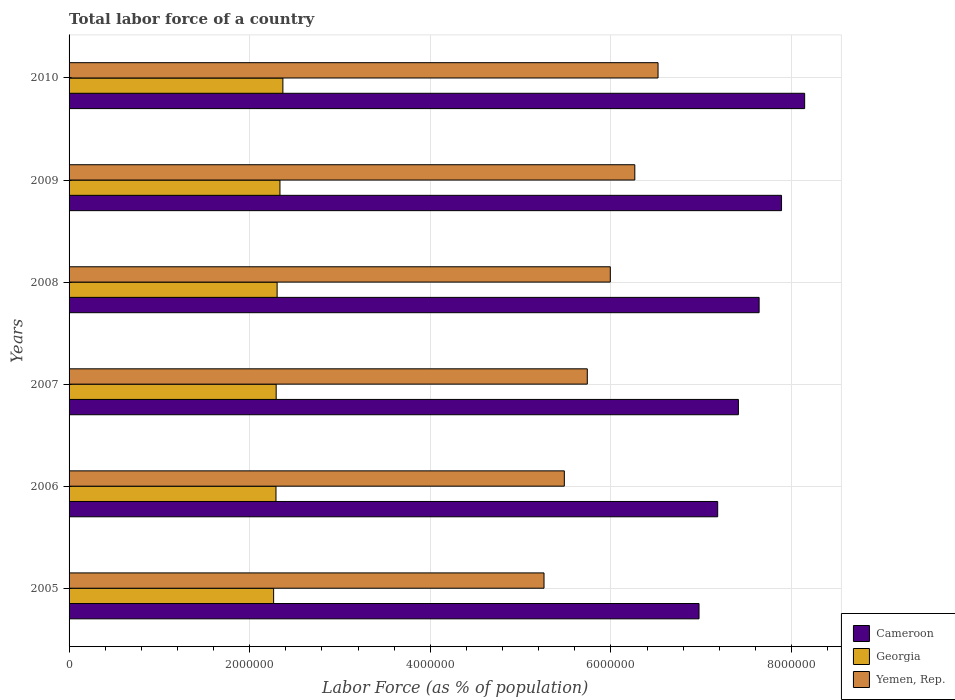Are the number of bars on each tick of the Y-axis equal?
Give a very brief answer. Yes. How many bars are there on the 3rd tick from the top?
Provide a succinct answer. 3. What is the label of the 1st group of bars from the top?
Provide a succinct answer. 2010. What is the percentage of labor force in Cameroon in 2010?
Provide a succinct answer. 8.14e+06. Across all years, what is the maximum percentage of labor force in Cameroon?
Offer a very short reply. 8.14e+06. Across all years, what is the minimum percentage of labor force in Yemen, Rep.?
Your response must be concise. 5.26e+06. In which year was the percentage of labor force in Yemen, Rep. maximum?
Offer a terse response. 2010. What is the total percentage of labor force in Cameroon in the graph?
Ensure brevity in your answer.  4.52e+07. What is the difference between the percentage of labor force in Georgia in 2006 and that in 2010?
Offer a terse response. -7.65e+04. What is the difference between the percentage of labor force in Georgia in 2010 and the percentage of labor force in Cameroon in 2008?
Provide a succinct answer. -5.27e+06. What is the average percentage of labor force in Cameroon per year?
Your answer should be very brief. 7.54e+06. In the year 2005, what is the difference between the percentage of labor force in Georgia and percentage of labor force in Cameroon?
Provide a succinct answer. -4.71e+06. In how many years, is the percentage of labor force in Georgia greater than 1600000 %?
Offer a very short reply. 6. What is the ratio of the percentage of labor force in Cameroon in 2006 to that in 2009?
Offer a terse response. 0.91. Is the percentage of labor force in Yemen, Rep. in 2008 less than that in 2010?
Provide a succinct answer. Yes. What is the difference between the highest and the second highest percentage of labor force in Cameroon?
Make the answer very short. 2.56e+05. What is the difference between the highest and the lowest percentage of labor force in Georgia?
Provide a short and direct response. 1.03e+05. In how many years, is the percentage of labor force in Yemen, Rep. greater than the average percentage of labor force in Yemen, Rep. taken over all years?
Your answer should be very brief. 3. What does the 3rd bar from the top in 2006 represents?
Make the answer very short. Cameroon. What does the 3rd bar from the bottom in 2008 represents?
Give a very brief answer. Yemen, Rep. How many bars are there?
Make the answer very short. 18. Are all the bars in the graph horizontal?
Offer a very short reply. Yes. What is the difference between two consecutive major ticks on the X-axis?
Offer a terse response. 2.00e+06. Does the graph contain any zero values?
Give a very brief answer. No. Does the graph contain grids?
Provide a short and direct response. Yes. Where does the legend appear in the graph?
Your answer should be very brief. Bottom right. What is the title of the graph?
Keep it short and to the point. Total labor force of a country. Does "Latvia" appear as one of the legend labels in the graph?
Provide a short and direct response. No. What is the label or title of the X-axis?
Keep it short and to the point. Labor Force (as % of population). What is the Labor Force (as % of population) of Cameroon in 2005?
Provide a short and direct response. 6.98e+06. What is the Labor Force (as % of population) of Georgia in 2005?
Ensure brevity in your answer.  2.26e+06. What is the Labor Force (as % of population) in Yemen, Rep. in 2005?
Your answer should be very brief. 5.26e+06. What is the Labor Force (as % of population) of Cameroon in 2006?
Keep it short and to the point. 7.18e+06. What is the Labor Force (as % of population) of Georgia in 2006?
Give a very brief answer. 2.29e+06. What is the Labor Force (as % of population) in Yemen, Rep. in 2006?
Give a very brief answer. 5.48e+06. What is the Labor Force (as % of population) in Cameroon in 2007?
Ensure brevity in your answer.  7.41e+06. What is the Labor Force (as % of population) of Georgia in 2007?
Provide a short and direct response. 2.29e+06. What is the Labor Force (as % of population) in Yemen, Rep. in 2007?
Keep it short and to the point. 5.74e+06. What is the Labor Force (as % of population) of Cameroon in 2008?
Make the answer very short. 7.64e+06. What is the Labor Force (as % of population) of Georgia in 2008?
Give a very brief answer. 2.30e+06. What is the Labor Force (as % of population) in Yemen, Rep. in 2008?
Keep it short and to the point. 5.99e+06. What is the Labor Force (as % of population) of Cameroon in 2009?
Offer a very short reply. 7.89e+06. What is the Labor Force (as % of population) of Georgia in 2009?
Provide a succinct answer. 2.33e+06. What is the Labor Force (as % of population) of Yemen, Rep. in 2009?
Offer a terse response. 6.26e+06. What is the Labor Force (as % of population) in Cameroon in 2010?
Give a very brief answer. 8.14e+06. What is the Labor Force (as % of population) in Georgia in 2010?
Ensure brevity in your answer.  2.37e+06. What is the Labor Force (as % of population) of Yemen, Rep. in 2010?
Keep it short and to the point. 6.52e+06. Across all years, what is the maximum Labor Force (as % of population) in Cameroon?
Provide a succinct answer. 8.14e+06. Across all years, what is the maximum Labor Force (as % of population) of Georgia?
Your answer should be very brief. 2.37e+06. Across all years, what is the maximum Labor Force (as % of population) of Yemen, Rep.?
Offer a terse response. 6.52e+06. Across all years, what is the minimum Labor Force (as % of population) in Cameroon?
Offer a very short reply. 6.98e+06. Across all years, what is the minimum Labor Force (as % of population) of Georgia?
Provide a short and direct response. 2.26e+06. Across all years, what is the minimum Labor Force (as % of population) of Yemen, Rep.?
Give a very brief answer. 5.26e+06. What is the total Labor Force (as % of population) in Cameroon in the graph?
Offer a very short reply. 4.52e+07. What is the total Labor Force (as % of population) in Georgia in the graph?
Keep it short and to the point. 1.39e+07. What is the total Labor Force (as % of population) of Yemen, Rep. in the graph?
Offer a very short reply. 3.53e+07. What is the difference between the Labor Force (as % of population) of Cameroon in 2005 and that in 2006?
Give a very brief answer. -2.07e+05. What is the difference between the Labor Force (as % of population) of Georgia in 2005 and that in 2006?
Offer a very short reply. -2.62e+04. What is the difference between the Labor Force (as % of population) of Yemen, Rep. in 2005 and that in 2006?
Your answer should be very brief. -2.25e+05. What is the difference between the Labor Force (as % of population) of Cameroon in 2005 and that in 2007?
Ensure brevity in your answer.  -4.36e+05. What is the difference between the Labor Force (as % of population) of Georgia in 2005 and that in 2007?
Keep it short and to the point. -2.83e+04. What is the difference between the Labor Force (as % of population) in Yemen, Rep. in 2005 and that in 2007?
Ensure brevity in your answer.  -4.79e+05. What is the difference between the Labor Force (as % of population) in Cameroon in 2005 and that in 2008?
Provide a succinct answer. -6.65e+05. What is the difference between the Labor Force (as % of population) of Georgia in 2005 and that in 2008?
Your answer should be compact. -3.87e+04. What is the difference between the Labor Force (as % of population) of Yemen, Rep. in 2005 and that in 2008?
Offer a very short reply. -7.34e+05. What is the difference between the Labor Force (as % of population) of Cameroon in 2005 and that in 2009?
Provide a short and direct response. -9.14e+05. What is the difference between the Labor Force (as % of population) of Georgia in 2005 and that in 2009?
Give a very brief answer. -7.01e+04. What is the difference between the Labor Force (as % of population) in Yemen, Rep. in 2005 and that in 2009?
Ensure brevity in your answer.  -1.01e+06. What is the difference between the Labor Force (as % of population) in Cameroon in 2005 and that in 2010?
Offer a terse response. -1.17e+06. What is the difference between the Labor Force (as % of population) in Georgia in 2005 and that in 2010?
Ensure brevity in your answer.  -1.03e+05. What is the difference between the Labor Force (as % of population) of Yemen, Rep. in 2005 and that in 2010?
Ensure brevity in your answer.  -1.26e+06. What is the difference between the Labor Force (as % of population) of Cameroon in 2006 and that in 2007?
Provide a succinct answer. -2.29e+05. What is the difference between the Labor Force (as % of population) in Georgia in 2006 and that in 2007?
Offer a very short reply. -2160. What is the difference between the Labor Force (as % of population) in Yemen, Rep. in 2006 and that in 2007?
Your response must be concise. -2.54e+05. What is the difference between the Labor Force (as % of population) in Cameroon in 2006 and that in 2008?
Ensure brevity in your answer.  -4.59e+05. What is the difference between the Labor Force (as % of population) of Georgia in 2006 and that in 2008?
Provide a short and direct response. -1.26e+04. What is the difference between the Labor Force (as % of population) of Yemen, Rep. in 2006 and that in 2008?
Ensure brevity in your answer.  -5.09e+05. What is the difference between the Labor Force (as % of population) in Cameroon in 2006 and that in 2009?
Provide a succinct answer. -7.07e+05. What is the difference between the Labor Force (as % of population) in Georgia in 2006 and that in 2009?
Your answer should be compact. -4.40e+04. What is the difference between the Labor Force (as % of population) in Yemen, Rep. in 2006 and that in 2009?
Your answer should be compact. -7.80e+05. What is the difference between the Labor Force (as % of population) in Cameroon in 2006 and that in 2010?
Keep it short and to the point. -9.63e+05. What is the difference between the Labor Force (as % of population) of Georgia in 2006 and that in 2010?
Provide a succinct answer. -7.65e+04. What is the difference between the Labor Force (as % of population) of Yemen, Rep. in 2006 and that in 2010?
Your answer should be very brief. -1.04e+06. What is the difference between the Labor Force (as % of population) of Cameroon in 2007 and that in 2008?
Keep it short and to the point. -2.29e+05. What is the difference between the Labor Force (as % of population) of Georgia in 2007 and that in 2008?
Ensure brevity in your answer.  -1.04e+04. What is the difference between the Labor Force (as % of population) in Yemen, Rep. in 2007 and that in 2008?
Your response must be concise. -2.55e+05. What is the difference between the Labor Force (as % of population) of Cameroon in 2007 and that in 2009?
Give a very brief answer. -4.78e+05. What is the difference between the Labor Force (as % of population) in Georgia in 2007 and that in 2009?
Provide a short and direct response. -4.18e+04. What is the difference between the Labor Force (as % of population) in Yemen, Rep. in 2007 and that in 2009?
Ensure brevity in your answer.  -5.26e+05. What is the difference between the Labor Force (as % of population) in Cameroon in 2007 and that in 2010?
Your answer should be compact. -7.33e+05. What is the difference between the Labor Force (as % of population) of Georgia in 2007 and that in 2010?
Your answer should be compact. -7.43e+04. What is the difference between the Labor Force (as % of population) of Yemen, Rep. in 2007 and that in 2010?
Offer a terse response. -7.83e+05. What is the difference between the Labor Force (as % of population) of Cameroon in 2008 and that in 2009?
Offer a very short reply. -2.48e+05. What is the difference between the Labor Force (as % of population) in Georgia in 2008 and that in 2009?
Provide a short and direct response. -3.14e+04. What is the difference between the Labor Force (as % of population) in Yemen, Rep. in 2008 and that in 2009?
Provide a short and direct response. -2.71e+05. What is the difference between the Labor Force (as % of population) of Cameroon in 2008 and that in 2010?
Provide a succinct answer. -5.04e+05. What is the difference between the Labor Force (as % of population) of Georgia in 2008 and that in 2010?
Your answer should be very brief. -6.39e+04. What is the difference between the Labor Force (as % of population) in Yemen, Rep. in 2008 and that in 2010?
Provide a succinct answer. -5.28e+05. What is the difference between the Labor Force (as % of population) in Cameroon in 2009 and that in 2010?
Offer a very short reply. -2.56e+05. What is the difference between the Labor Force (as % of population) of Georgia in 2009 and that in 2010?
Your answer should be compact. -3.25e+04. What is the difference between the Labor Force (as % of population) of Yemen, Rep. in 2009 and that in 2010?
Keep it short and to the point. -2.57e+05. What is the difference between the Labor Force (as % of population) in Cameroon in 2005 and the Labor Force (as % of population) in Georgia in 2006?
Give a very brief answer. 4.68e+06. What is the difference between the Labor Force (as % of population) in Cameroon in 2005 and the Labor Force (as % of population) in Yemen, Rep. in 2006?
Ensure brevity in your answer.  1.49e+06. What is the difference between the Labor Force (as % of population) in Georgia in 2005 and the Labor Force (as % of population) in Yemen, Rep. in 2006?
Make the answer very short. -3.22e+06. What is the difference between the Labor Force (as % of population) in Cameroon in 2005 and the Labor Force (as % of population) in Georgia in 2007?
Your answer should be very brief. 4.68e+06. What is the difference between the Labor Force (as % of population) in Cameroon in 2005 and the Labor Force (as % of population) in Yemen, Rep. in 2007?
Your answer should be very brief. 1.24e+06. What is the difference between the Labor Force (as % of population) of Georgia in 2005 and the Labor Force (as % of population) of Yemen, Rep. in 2007?
Make the answer very short. -3.47e+06. What is the difference between the Labor Force (as % of population) in Cameroon in 2005 and the Labor Force (as % of population) in Georgia in 2008?
Keep it short and to the point. 4.67e+06. What is the difference between the Labor Force (as % of population) in Cameroon in 2005 and the Labor Force (as % of population) in Yemen, Rep. in 2008?
Offer a very short reply. 9.82e+05. What is the difference between the Labor Force (as % of population) in Georgia in 2005 and the Labor Force (as % of population) in Yemen, Rep. in 2008?
Your answer should be very brief. -3.73e+06. What is the difference between the Labor Force (as % of population) of Cameroon in 2005 and the Labor Force (as % of population) of Georgia in 2009?
Your response must be concise. 4.64e+06. What is the difference between the Labor Force (as % of population) in Cameroon in 2005 and the Labor Force (as % of population) in Yemen, Rep. in 2009?
Give a very brief answer. 7.11e+05. What is the difference between the Labor Force (as % of population) of Georgia in 2005 and the Labor Force (as % of population) of Yemen, Rep. in 2009?
Your answer should be very brief. -4.00e+06. What is the difference between the Labor Force (as % of population) in Cameroon in 2005 and the Labor Force (as % of population) in Georgia in 2010?
Give a very brief answer. 4.61e+06. What is the difference between the Labor Force (as % of population) in Cameroon in 2005 and the Labor Force (as % of population) in Yemen, Rep. in 2010?
Offer a very short reply. 4.54e+05. What is the difference between the Labor Force (as % of population) of Georgia in 2005 and the Labor Force (as % of population) of Yemen, Rep. in 2010?
Offer a very short reply. -4.26e+06. What is the difference between the Labor Force (as % of population) of Cameroon in 2006 and the Labor Force (as % of population) of Georgia in 2007?
Ensure brevity in your answer.  4.89e+06. What is the difference between the Labor Force (as % of population) in Cameroon in 2006 and the Labor Force (as % of population) in Yemen, Rep. in 2007?
Provide a short and direct response. 1.44e+06. What is the difference between the Labor Force (as % of population) of Georgia in 2006 and the Labor Force (as % of population) of Yemen, Rep. in 2007?
Keep it short and to the point. -3.45e+06. What is the difference between the Labor Force (as % of population) of Cameroon in 2006 and the Labor Force (as % of population) of Georgia in 2008?
Ensure brevity in your answer.  4.88e+06. What is the difference between the Labor Force (as % of population) in Cameroon in 2006 and the Labor Force (as % of population) in Yemen, Rep. in 2008?
Your answer should be very brief. 1.19e+06. What is the difference between the Labor Force (as % of population) of Georgia in 2006 and the Labor Force (as % of population) of Yemen, Rep. in 2008?
Provide a short and direct response. -3.70e+06. What is the difference between the Labor Force (as % of population) in Cameroon in 2006 and the Labor Force (as % of population) in Georgia in 2009?
Give a very brief answer. 4.85e+06. What is the difference between the Labor Force (as % of population) of Cameroon in 2006 and the Labor Force (as % of population) of Yemen, Rep. in 2009?
Ensure brevity in your answer.  9.18e+05. What is the difference between the Labor Force (as % of population) in Georgia in 2006 and the Labor Force (as % of population) in Yemen, Rep. in 2009?
Your response must be concise. -3.97e+06. What is the difference between the Labor Force (as % of population) of Cameroon in 2006 and the Labor Force (as % of population) of Georgia in 2010?
Your response must be concise. 4.81e+06. What is the difference between the Labor Force (as % of population) of Cameroon in 2006 and the Labor Force (as % of population) of Yemen, Rep. in 2010?
Make the answer very short. 6.61e+05. What is the difference between the Labor Force (as % of population) of Georgia in 2006 and the Labor Force (as % of population) of Yemen, Rep. in 2010?
Your answer should be compact. -4.23e+06. What is the difference between the Labor Force (as % of population) of Cameroon in 2007 and the Labor Force (as % of population) of Georgia in 2008?
Provide a short and direct response. 5.11e+06. What is the difference between the Labor Force (as % of population) in Cameroon in 2007 and the Labor Force (as % of population) in Yemen, Rep. in 2008?
Offer a terse response. 1.42e+06. What is the difference between the Labor Force (as % of population) in Georgia in 2007 and the Labor Force (as % of population) in Yemen, Rep. in 2008?
Your answer should be very brief. -3.70e+06. What is the difference between the Labor Force (as % of population) in Cameroon in 2007 and the Labor Force (as % of population) in Georgia in 2009?
Your response must be concise. 5.08e+06. What is the difference between the Labor Force (as % of population) in Cameroon in 2007 and the Labor Force (as % of population) in Yemen, Rep. in 2009?
Your response must be concise. 1.15e+06. What is the difference between the Labor Force (as % of population) of Georgia in 2007 and the Labor Force (as % of population) of Yemen, Rep. in 2009?
Ensure brevity in your answer.  -3.97e+06. What is the difference between the Labor Force (as % of population) in Cameroon in 2007 and the Labor Force (as % of population) in Georgia in 2010?
Make the answer very short. 5.04e+06. What is the difference between the Labor Force (as % of population) of Cameroon in 2007 and the Labor Force (as % of population) of Yemen, Rep. in 2010?
Your response must be concise. 8.90e+05. What is the difference between the Labor Force (as % of population) of Georgia in 2007 and the Labor Force (as % of population) of Yemen, Rep. in 2010?
Offer a very short reply. -4.23e+06. What is the difference between the Labor Force (as % of population) in Cameroon in 2008 and the Labor Force (as % of population) in Georgia in 2009?
Offer a very short reply. 5.31e+06. What is the difference between the Labor Force (as % of population) in Cameroon in 2008 and the Labor Force (as % of population) in Yemen, Rep. in 2009?
Give a very brief answer. 1.38e+06. What is the difference between the Labor Force (as % of population) of Georgia in 2008 and the Labor Force (as % of population) of Yemen, Rep. in 2009?
Give a very brief answer. -3.96e+06. What is the difference between the Labor Force (as % of population) in Cameroon in 2008 and the Labor Force (as % of population) in Georgia in 2010?
Ensure brevity in your answer.  5.27e+06. What is the difference between the Labor Force (as % of population) in Cameroon in 2008 and the Labor Force (as % of population) in Yemen, Rep. in 2010?
Provide a short and direct response. 1.12e+06. What is the difference between the Labor Force (as % of population) of Georgia in 2008 and the Labor Force (as % of population) of Yemen, Rep. in 2010?
Your answer should be very brief. -4.22e+06. What is the difference between the Labor Force (as % of population) of Cameroon in 2009 and the Labor Force (as % of population) of Georgia in 2010?
Provide a short and direct response. 5.52e+06. What is the difference between the Labor Force (as % of population) of Cameroon in 2009 and the Labor Force (as % of population) of Yemen, Rep. in 2010?
Your response must be concise. 1.37e+06. What is the difference between the Labor Force (as % of population) of Georgia in 2009 and the Labor Force (as % of population) of Yemen, Rep. in 2010?
Provide a short and direct response. -4.19e+06. What is the average Labor Force (as % of population) in Cameroon per year?
Keep it short and to the point. 7.54e+06. What is the average Labor Force (as % of population) in Georgia per year?
Give a very brief answer. 2.31e+06. What is the average Labor Force (as % of population) in Yemen, Rep. per year?
Offer a very short reply. 5.88e+06. In the year 2005, what is the difference between the Labor Force (as % of population) of Cameroon and Labor Force (as % of population) of Georgia?
Provide a succinct answer. 4.71e+06. In the year 2005, what is the difference between the Labor Force (as % of population) in Cameroon and Labor Force (as % of population) in Yemen, Rep.?
Offer a very short reply. 1.72e+06. In the year 2005, what is the difference between the Labor Force (as % of population) in Georgia and Labor Force (as % of population) in Yemen, Rep.?
Make the answer very short. -2.99e+06. In the year 2006, what is the difference between the Labor Force (as % of population) in Cameroon and Labor Force (as % of population) in Georgia?
Provide a short and direct response. 4.89e+06. In the year 2006, what is the difference between the Labor Force (as % of population) in Cameroon and Labor Force (as % of population) in Yemen, Rep.?
Provide a succinct answer. 1.70e+06. In the year 2006, what is the difference between the Labor Force (as % of population) of Georgia and Labor Force (as % of population) of Yemen, Rep.?
Make the answer very short. -3.19e+06. In the year 2007, what is the difference between the Labor Force (as % of population) of Cameroon and Labor Force (as % of population) of Georgia?
Keep it short and to the point. 5.12e+06. In the year 2007, what is the difference between the Labor Force (as % of population) of Cameroon and Labor Force (as % of population) of Yemen, Rep.?
Make the answer very short. 1.67e+06. In the year 2007, what is the difference between the Labor Force (as % of population) in Georgia and Labor Force (as % of population) in Yemen, Rep.?
Provide a succinct answer. -3.44e+06. In the year 2008, what is the difference between the Labor Force (as % of population) of Cameroon and Labor Force (as % of population) of Georgia?
Your answer should be compact. 5.34e+06. In the year 2008, what is the difference between the Labor Force (as % of population) of Cameroon and Labor Force (as % of population) of Yemen, Rep.?
Give a very brief answer. 1.65e+06. In the year 2008, what is the difference between the Labor Force (as % of population) of Georgia and Labor Force (as % of population) of Yemen, Rep.?
Keep it short and to the point. -3.69e+06. In the year 2009, what is the difference between the Labor Force (as % of population) of Cameroon and Labor Force (as % of population) of Georgia?
Make the answer very short. 5.55e+06. In the year 2009, what is the difference between the Labor Force (as % of population) of Cameroon and Labor Force (as % of population) of Yemen, Rep.?
Offer a very short reply. 1.62e+06. In the year 2009, what is the difference between the Labor Force (as % of population) of Georgia and Labor Force (as % of population) of Yemen, Rep.?
Make the answer very short. -3.93e+06. In the year 2010, what is the difference between the Labor Force (as % of population) of Cameroon and Labor Force (as % of population) of Georgia?
Make the answer very short. 5.78e+06. In the year 2010, what is the difference between the Labor Force (as % of population) in Cameroon and Labor Force (as % of population) in Yemen, Rep.?
Your answer should be very brief. 1.62e+06. In the year 2010, what is the difference between the Labor Force (as % of population) of Georgia and Labor Force (as % of population) of Yemen, Rep.?
Your response must be concise. -4.15e+06. What is the ratio of the Labor Force (as % of population) of Cameroon in 2005 to that in 2006?
Make the answer very short. 0.97. What is the ratio of the Labor Force (as % of population) of Yemen, Rep. in 2005 to that in 2006?
Your response must be concise. 0.96. What is the ratio of the Labor Force (as % of population) in Cameroon in 2005 to that in 2007?
Your answer should be compact. 0.94. What is the ratio of the Labor Force (as % of population) in Georgia in 2005 to that in 2007?
Give a very brief answer. 0.99. What is the ratio of the Labor Force (as % of population) in Yemen, Rep. in 2005 to that in 2007?
Your answer should be compact. 0.92. What is the ratio of the Labor Force (as % of population) in Cameroon in 2005 to that in 2008?
Provide a succinct answer. 0.91. What is the ratio of the Labor Force (as % of population) in Georgia in 2005 to that in 2008?
Offer a terse response. 0.98. What is the ratio of the Labor Force (as % of population) of Yemen, Rep. in 2005 to that in 2008?
Make the answer very short. 0.88. What is the ratio of the Labor Force (as % of population) in Cameroon in 2005 to that in 2009?
Provide a short and direct response. 0.88. What is the ratio of the Labor Force (as % of population) in Yemen, Rep. in 2005 to that in 2009?
Ensure brevity in your answer.  0.84. What is the ratio of the Labor Force (as % of population) of Cameroon in 2005 to that in 2010?
Make the answer very short. 0.86. What is the ratio of the Labor Force (as % of population) of Georgia in 2005 to that in 2010?
Make the answer very short. 0.96. What is the ratio of the Labor Force (as % of population) of Yemen, Rep. in 2005 to that in 2010?
Offer a very short reply. 0.81. What is the ratio of the Labor Force (as % of population) in Cameroon in 2006 to that in 2007?
Offer a very short reply. 0.97. What is the ratio of the Labor Force (as % of population) of Georgia in 2006 to that in 2007?
Your response must be concise. 1. What is the ratio of the Labor Force (as % of population) of Yemen, Rep. in 2006 to that in 2007?
Provide a succinct answer. 0.96. What is the ratio of the Labor Force (as % of population) in Cameroon in 2006 to that in 2008?
Ensure brevity in your answer.  0.94. What is the ratio of the Labor Force (as % of population) in Georgia in 2006 to that in 2008?
Your response must be concise. 0.99. What is the ratio of the Labor Force (as % of population) of Yemen, Rep. in 2006 to that in 2008?
Give a very brief answer. 0.92. What is the ratio of the Labor Force (as % of population) in Cameroon in 2006 to that in 2009?
Ensure brevity in your answer.  0.91. What is the ratio of the Labor Force (as % of population) in Georgia in 2006 to that in 2009?
Your answer should be very brief. 0.98. What is the ratio of the Labor Force (as % of population) of Yemen, Rep. in 2006 to that in 2009?
Provide a succinct answer. 0.88. What is the ratio of the Labor Force (as % of population) of Cameroon in 2006 to that in 2010?
Your answer should be compact. 0.88. What is the ratio of the Labor Force (as % of population) in Georgia in 2006 to that in 2010?
Offer a very short reply. 0.97. What is the ratio of the Labor Force (as % of population) in Yemen, Rep. in 2006 to that in 2010?
Ensure brevity in your answer.  0.84. What is the ratio of the Labor Force (as % of population) of Cameroon in 2007 to that in 2008?
Your answer should be compact. 0.97. What is the ratio of the Labor Force (as % of population) of Georgia in 2007 to that in 2008?
Keep it short and to the point. 1. What is the ratio of the Labor Force (as % of population) of Yemen, Rep. in 2007 to that in 2008?
Make the answer very short. 0.96. What is the ratio of the Labor Force (as % of population) of Cameroon in 2007 to that in 2009?
Your answer should be compact. 0.94. What is the ratio of the Labor Force (as % of population) in Georgia in 2007 to that in 2009?
Your answer should be very brief. 0.98. What is the ratio of the Labor Force (as % of population) of Yemen, Rep. in 2007 to that in 2009?
Your answer should be very brief. 0.92. What is the ratio of the Labor Force (as % of population) in Cameroon in 2007 to that in 2010?
Provide a succinct answer. 0.91. What is the ratio of the Labor Force (as % of population) of Georgia in 2007 to that in 2010?
Keep it short and to the point. 0.97. What is the ratio of the Labor Force (as % of population) of Yemen, Rep. in 2007 to that in 2010?
Your answer should be very brief. 0.88. What is the ratio of the Labor Force (as % of population) in Cameroon in 2008 to that in 2009?
Offer a terse response. 0.97. What is the ratio of the Labor Force (as % of population) of Georgia in 2008 to that in 2009?
Your answer should be compact. 0.99. What is the ratio of the Labor Force (as % of population) in Yemen, Rep. in 2008 to that in 2009?
Your answer should be very brief. 0.96. What is the ratio of the Labor Force (as % of population) in Cameroon in 2008 to that in 2010?
Keep it short and to the point. 0.94. What is the ratio of the Labor Force (as % of population) in Georgia in 2008 to that in 2010?
Offer a terse response. 0.97. What is the ratio of the Labor Force (as % of population) of Yemen, Rep. in 2008 to that in 2010?
Give a very brief answer. 0.92. What is the ratio of the Labor Force (as % of population) of Cameroon in 2009 to that in 2010?
Provide a succinct answer. 0.97. What is the ratio of the Labor Force (as % of population) of Georgia in 2009 to that in 2010?
Offer a terse response. 0.99. What is the ratio of the Labor Force (as % of population) of Yemen, Rep. in 2009 to that in 2010?
Keep it short and to the point. 0.96. What is the difference between the highest and the second highest Labor Force (as % of population) in Cameroon?
Your answer should be compact. 2.56e+05. What is the difference between the highest and the second highest Labor Force (as % of population) of Georgia?
Provide a succinct answer. 3.25e+04. What is the difference between the highest and the second highest Labor Force (as % of population) of Yemen, Rep.?
Your answer should be compact. 2.57e+05. What is the difference between the highest and the lowest Labor Force (as % of population) in Cameroon?
Offer a very short reply. 1.17e+06. What is the difference between the highest and the lowest Labor Force (as % of population) of Georgia?
Keep it short and to the point. 1.03e+05. What is the difference between the highest and the lowest Labor Force (as % of population) of Yemen, Rep.?
Provide a short and direct response. 1.26e+06. 